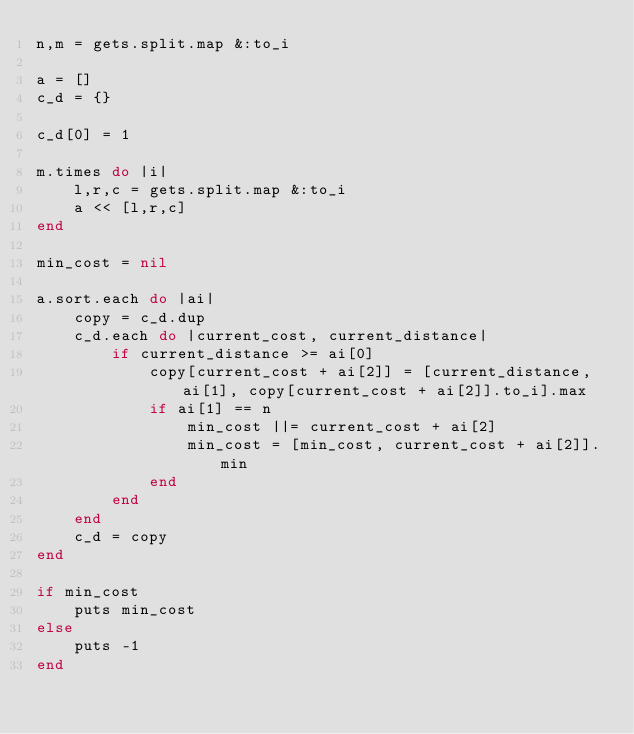Convert code to text. <code><loc_0><loc_0><loc_500><loc_500><_Ruby_>n,m = gets.split.map &:to_i

a = []
c_d = {}

c_d[0] = 1

m.times do |i|
    l,r,c = gets.split.map &:to_i
    a << [l,r,c]
end

min_cost = nil

a.sort.each do |ai|
    copy = c_d.dup
    c_d.each do |current_cost, current_distance|
        if current_distance >= ai[0]
            copy[current_cost + ai[2]] = [current_distance, ai[1], copy[current_cost + ai[2]].to_i].max
            if ai[1] == n
                min_cost ||= current_cost + ai[2]
                min_cost = [min_cost, current_cost + ai[2]].min
            end
        end
    end
    c_d = copy
end

if min_cost
    puts min_cost
else
    puts -1
end

</code> 